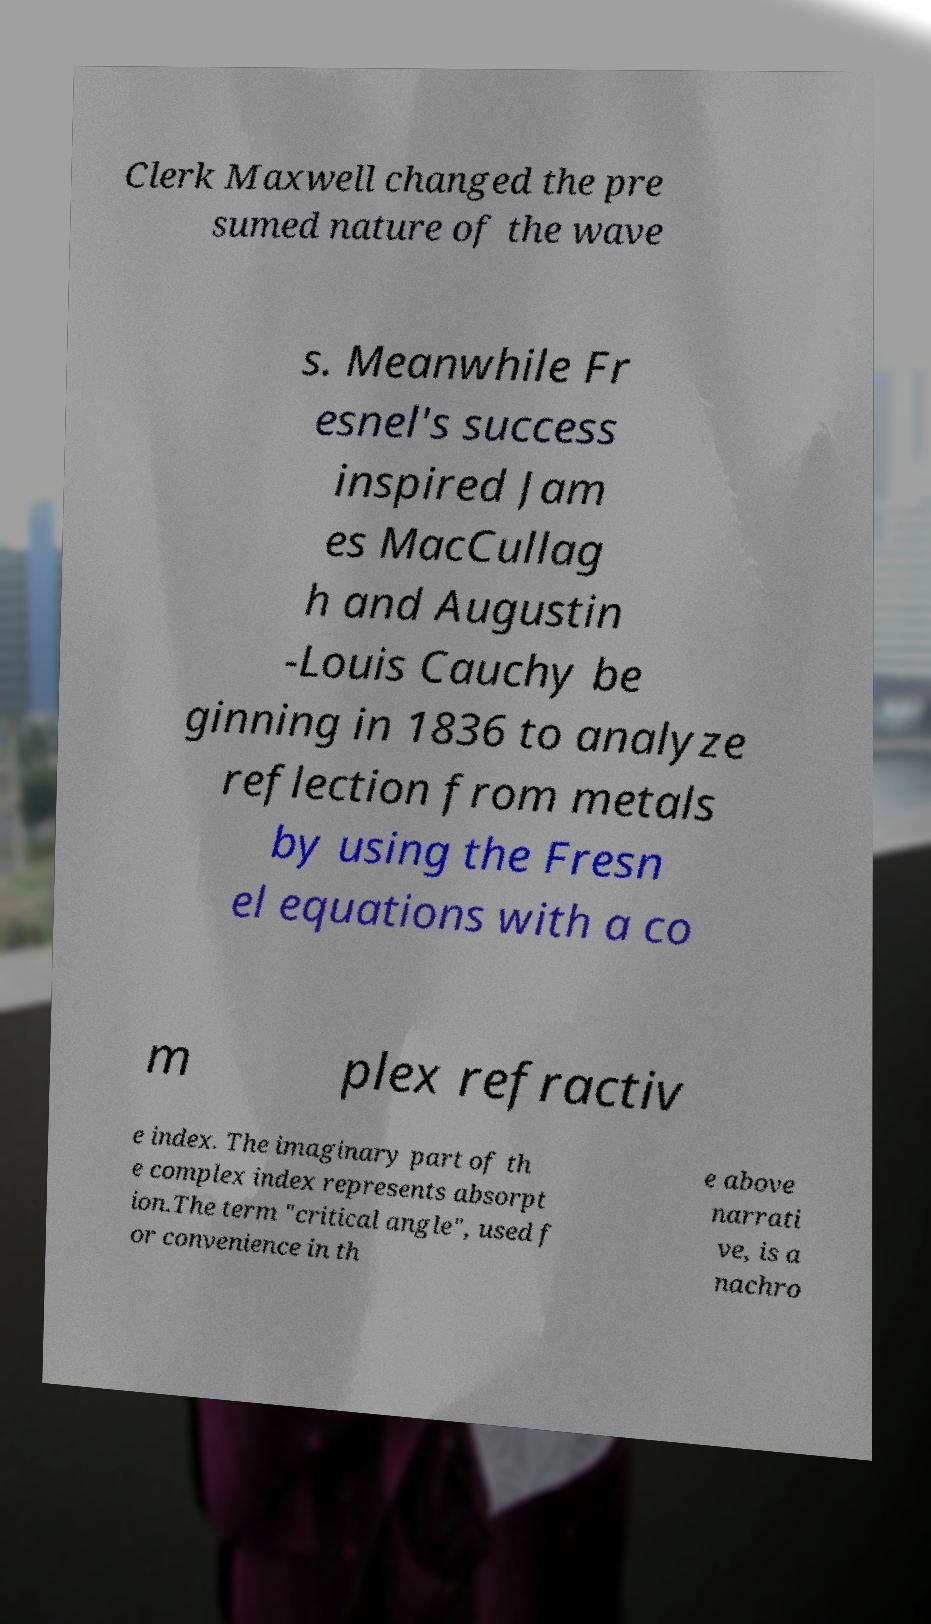What messages or text are displayed in this image? I need them in a readable, typed format. Clerk Maxwell changed the pre sumed nature of the wave s. Meanwhile Fr esnel's success inspired Jam es MacCullag h and Augustin -Louis Cauchy be ginning in 1836 to analyze reflection from metals by using the Fresn el equations with a co m plex refractiv e index. The imaginary part of th e complex index represents absorpt ion.The term "critical angle", used f or convenience in th e above narrati ve, is a nachro 